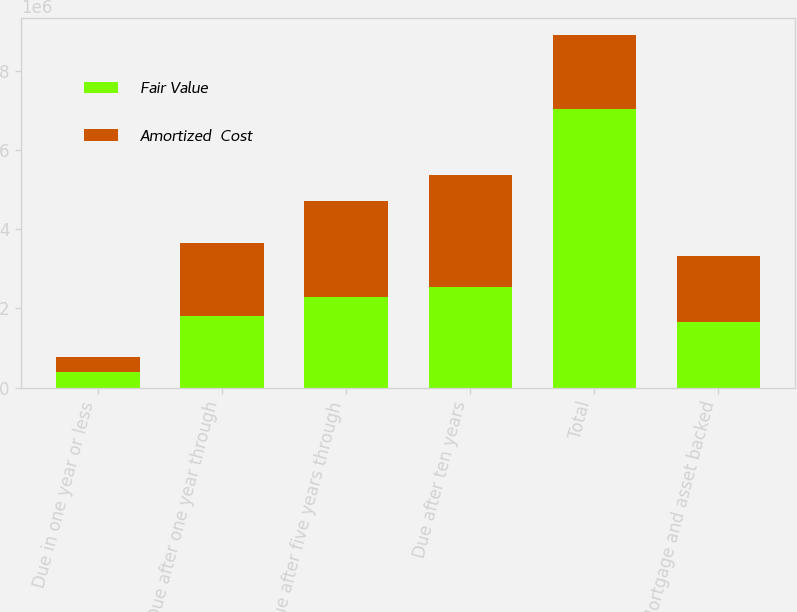Convert chart to OTSL. <chart><loc_0><loc_0><loc_500><loc_500><stacked_bar_chart><ecel><fcel>Due in one year or less<fcel>Due after one year through<fcel>Due after five years through<fcel>Due after ten years<fcel>Total<fcel>Mortgage and asset backed<nl><fcel>Fair Value<fcel>385656<fcel>1.79907e+06<fcel>2.29738e+06<fcel>2.54382e+06<fcel>7.02592e+06<fcel>1.65451e+06<nl><fcel>Amortized  Cost<fcel>391417<fcel>1.86387e+06<fcel>2.42352e+06<fcel>2.82181e+06<fcel>1.86387e+06<fcel>1.67732e+06<nl></chart> 